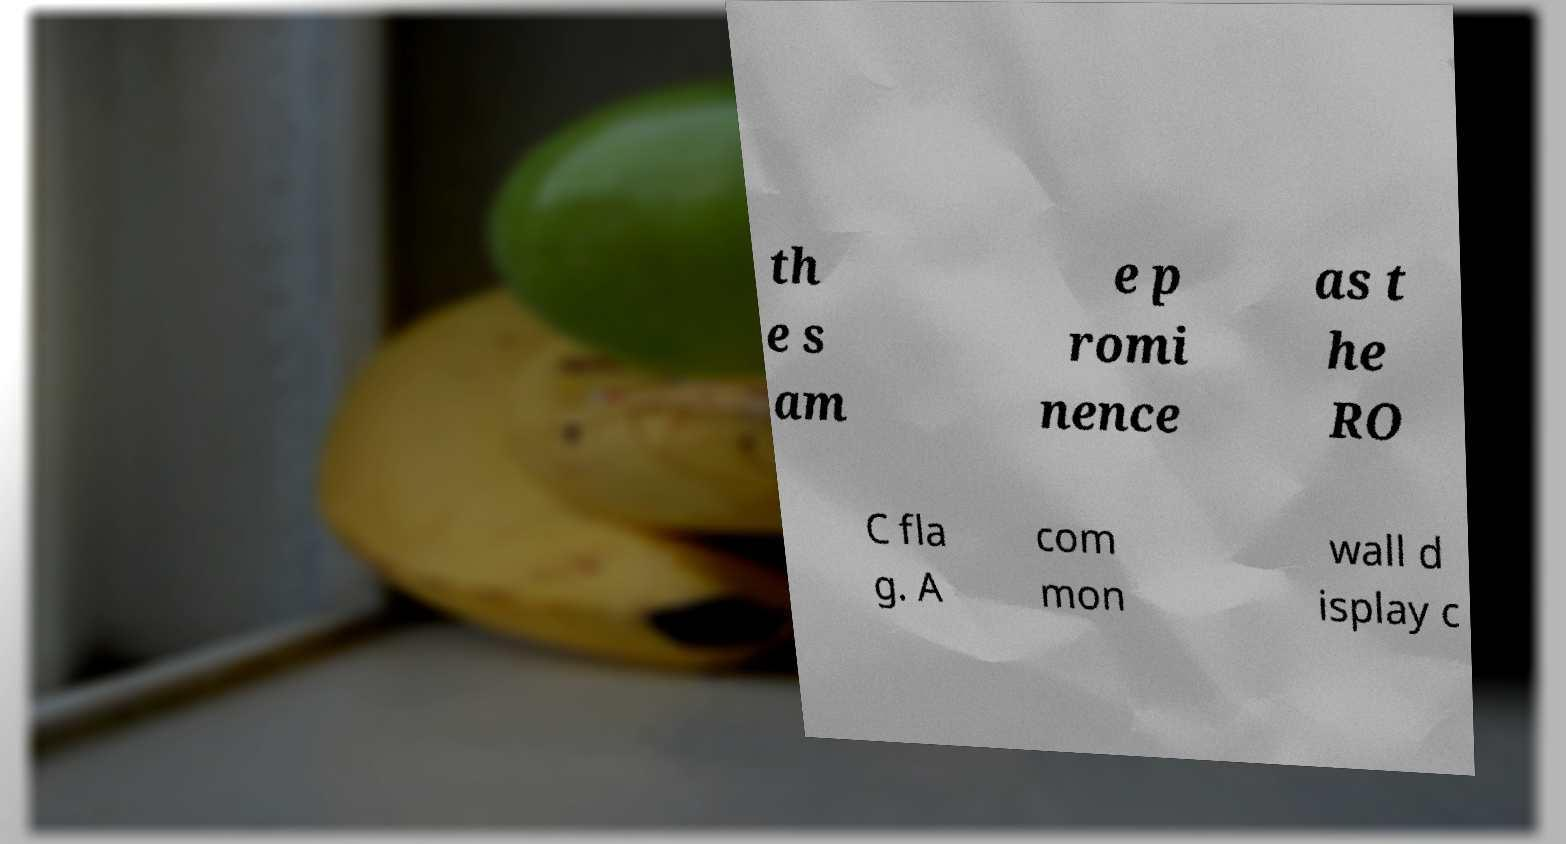I need the written content from this picture converted into text. Can you do that? th e s am e p romi nence as t he RO C fla g. A com mon wall d isplay c 